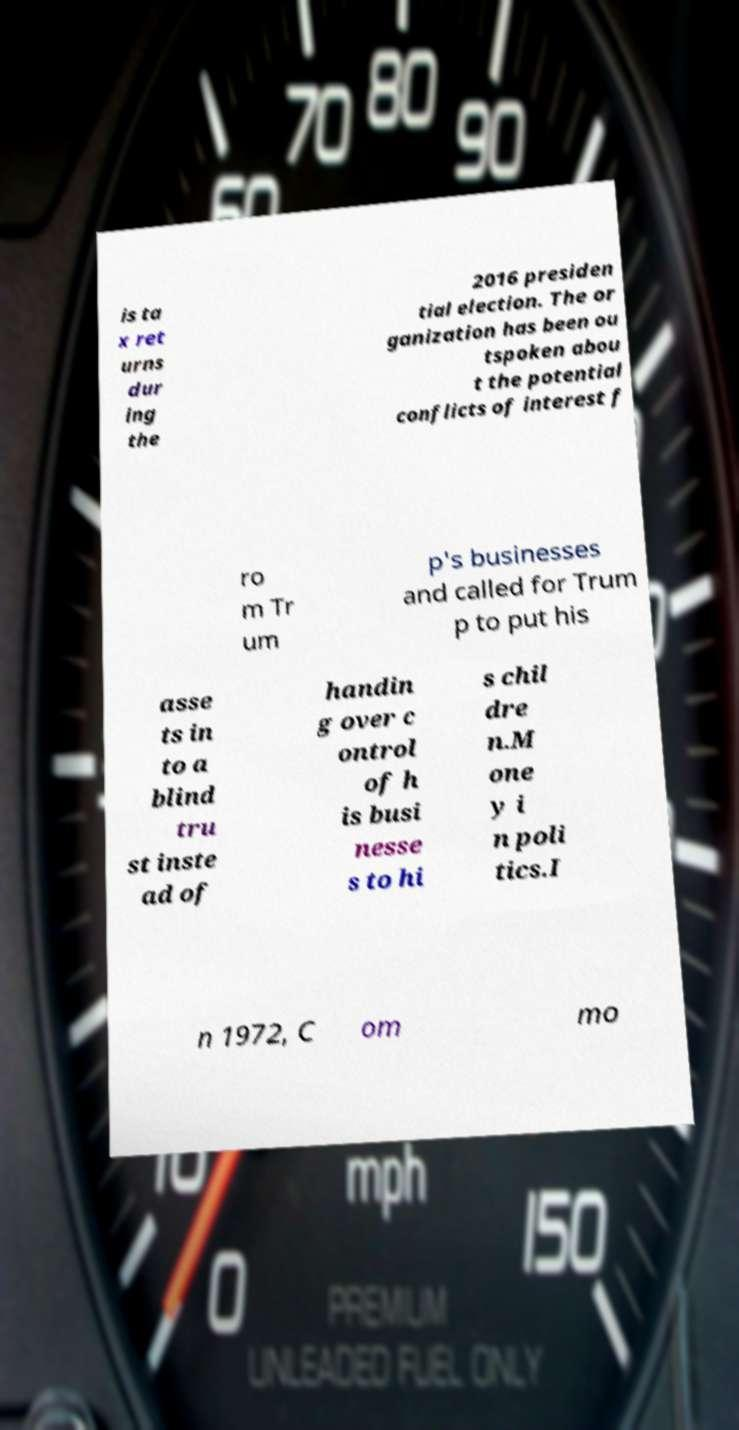I need the written content from this picture converted into text. Can you do that? is ta x ret urns dur ing the 2016 presiden tial election. The or ganization has been ou tspoken abou t the potential conflicts of interest f ro m Tr um p's businesses and called for Trum p to put his asse ts in to a blind tru st inste ad of handin g over c ontrol of h is busi nesse s to hi s chil dre n.M one y i n poli tics.I n 1972, C om mo 